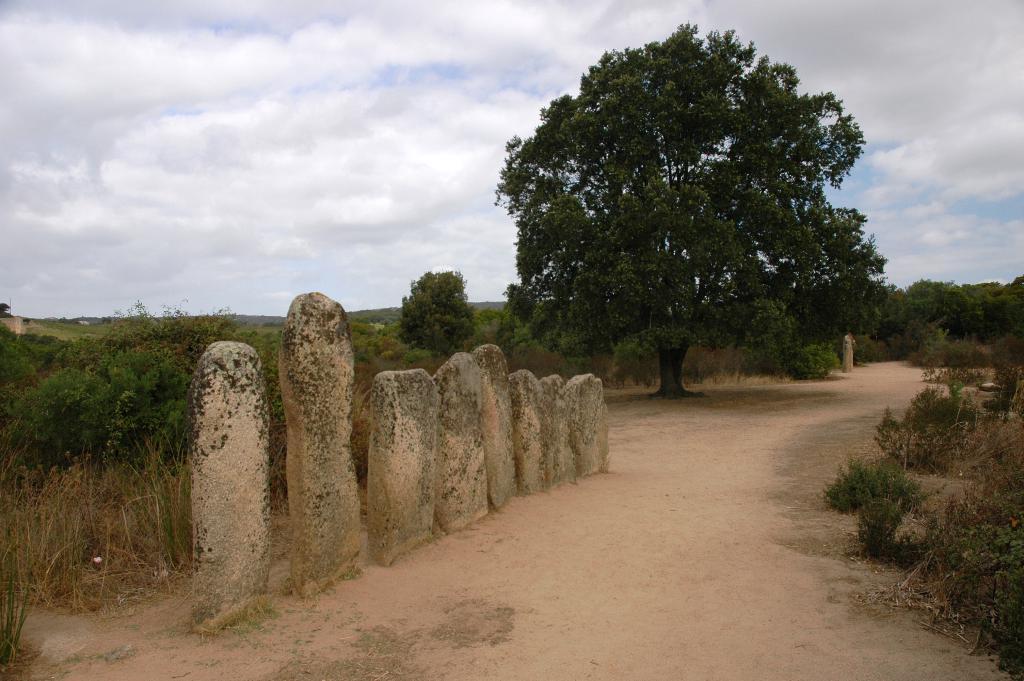Can you describe this image briefly? There are some stones present on the road as we can see at the bottom of this image, and there are some trees in the background. There is a cloudy sky at the top of this image. 